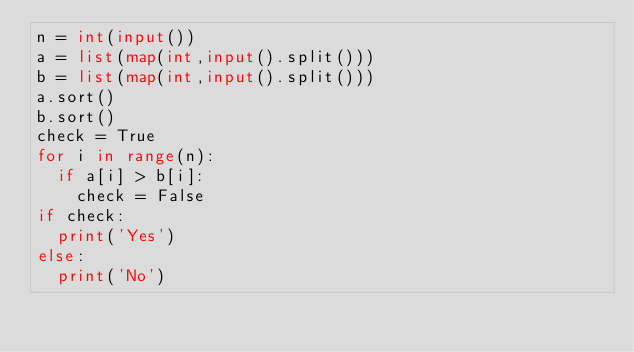<code> <loc_0><loc_0><loc_500><loc_500><_Python_>n = int(input())
a = list(map(int,input().split()))
b = list(map(int,input().split()))
a.sort()
b.sort()
check = True
for i in range(n):
	if a[i] > b[i]:
		check = False
if check:
	print('Yes')
else:
	print('No')</code> 